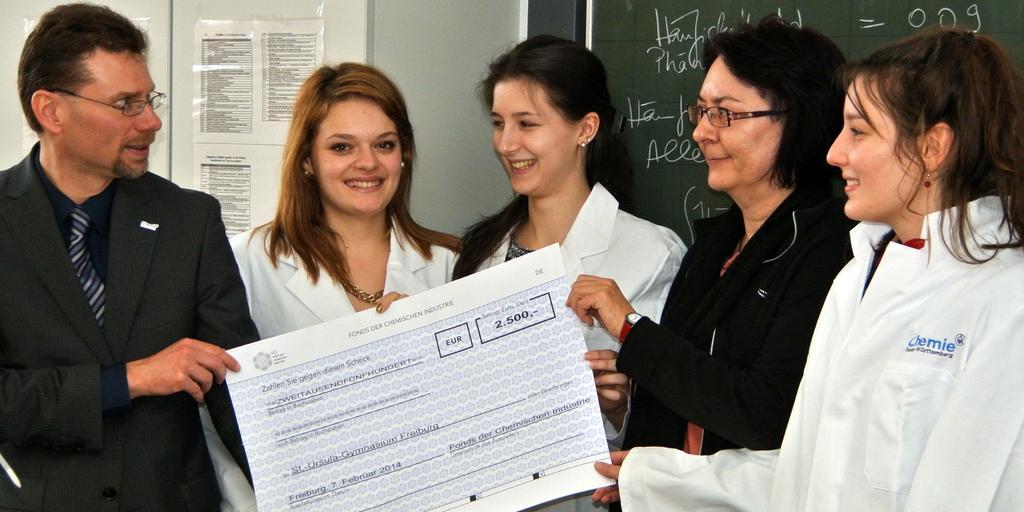In one or two sentences, can you explain what this image depicts? In this image we can see a group of people and few people holding an object. There are few papers on the notice board. There is some text written on the board in the image. 